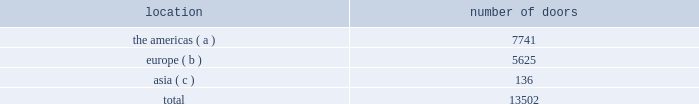Worldwide wholesale distribution channels the table presents the number of doors by geographic location in which products distributed by our wholesale segment were sold to consumers in our primary channels of distribution as of april 2 , 2016: .
( a ) includes the u.s. , canada , and latin america .
( b ) includes the middle east .
( c ) includes australia and new zealand .
We have three key wholesale customers that generate significant sales volume .
During fiscal 2016 , sales to our largest wholesale customer , macy's , inc .
( "macy's" ) , accounted for approximately 11% ( 11 % ) and 25% ( 25 % ) of our total net revenues and total wholesale net revenues , respectively .
Further , during fiscal 2016 , sales to our three largest wholesale customers , including macy's , accounted for approximately 24% ( 24 % ) and 53% ( 53 % ) of our total net revenues and total wholesale net revenues , respectively .
Our products are sold primarily by our own sales forces .
Our wholesale segment maintains its primary showrooms in new york city .
In addition , we maintain regional showrooms in milan , paris , london , munich , madrid , stockholm , and panama .
Shop-within-shops .
As a critical element of our distribution to department stores , we and our licensing partners utilize shop-within-shops to enhance brand recognition , to permit more complete merchandising of our lines by the department stores , and to differentiate the presentation of our products .
As of april 2 , 2016 , we had approximately 25000 shop-within-shops in our primary channels of distribution dedicated to our wholesale products worldwide .
The size of our shop-within-shops ranges from approximately 100 to 9200 square feet .
Shop-within-shop fixed assets primarily include items such as customized freestanding fixtures , wall cases and components , decorative items , and flooring .
We normally share in the cost of building out these shop-within-shops with our wholesale customers .
Basic stock replenishment program .
Basic products such as knit shirts , chino pants , oxford cloth shirts , select accessories , and home products can be ordered by our wholesale customers at any time through our basic stock replenishment program .
We generally ship these products within two to five days of order receipt .
Our retail segment our retail segment sells directly to customers throughout the world via our 493 retail stores , totaling approximately 3.8 million square feet , and 583 concession-based shop-within-shops , as well as through our various e-commerce sites .
The extension of our direct-to-consumer reach is one of our primary long-term strategic goals .
We operate our retail business using an omni-channel retailing strategy that seeks to deliver an integrated shopping experience with a consistent message of our brands and products to our customers , regardless of whether they are shopping for our products in one of our physical stores or online .
Ralph lauren stores our ralph lauren stores feature a broad range of apparel , accessories , watch and jewelry , fragrance , and home product assortments in an atmosphere reflecting the distinctive attitude and image of the ralph lauren , polo , double rl , and denim & supply brands , including exclusive merchandise that is not sold in department stores .
During fiscal 2016 , we opened 22 new ralph lauren stores and closed 21 stores .
Our ralph lauren stores are primarily situated in major upscale street locations and upscale regional malls , generally in large urban markets. .
What percentage of doors in the wholesale segment as of april 2 , 2016 where in the asia geography? 
Computations: (136 / 13502)
Answer: 0.01007. 